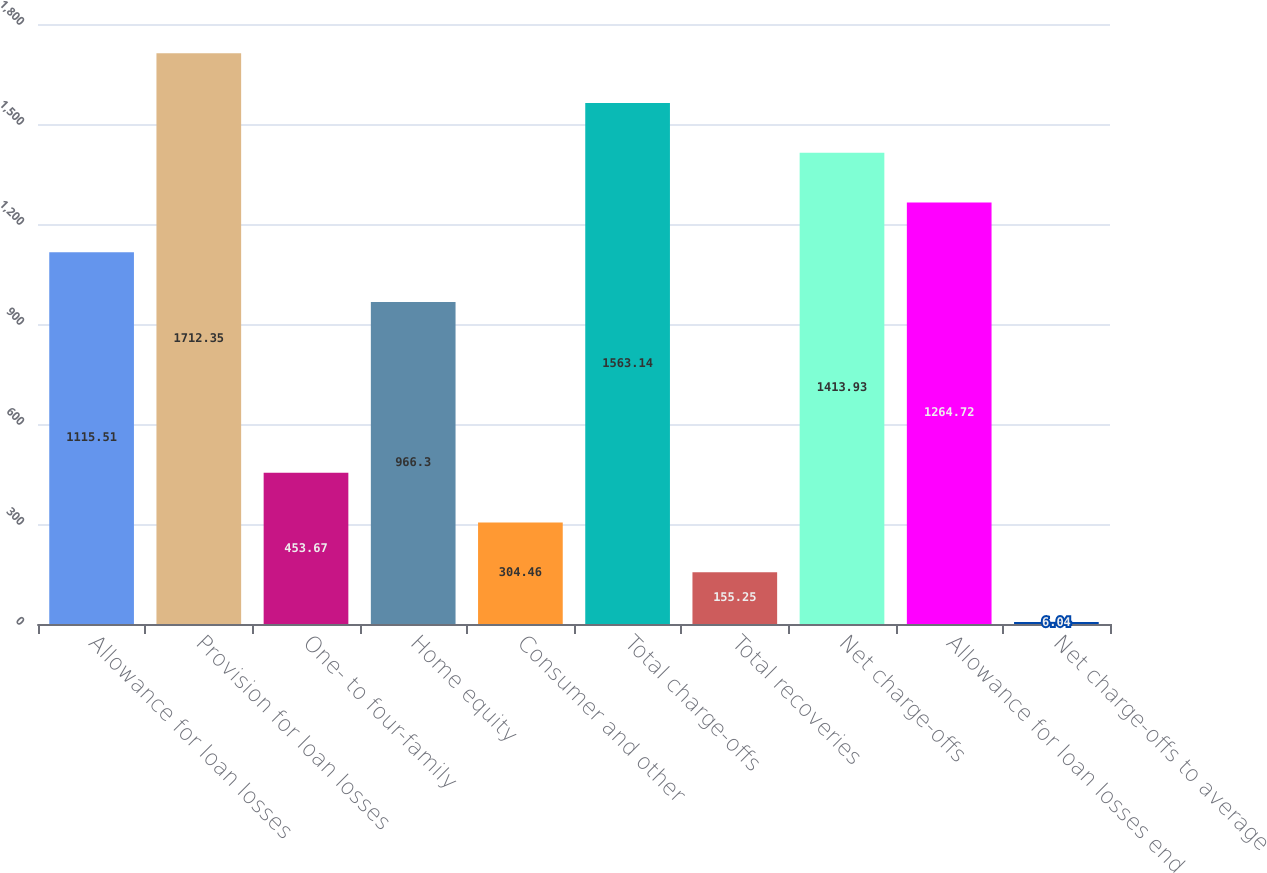<chart> <loc_0><loc_0><loc_500><loc_500><bar_chart><fcel>Allowance for loan losses<fcel>Provision for loan losses<fcel>One- to four-family<fcel>Home equity<fcel>Consumer and other<fcel>Total charge-offs<fcel>Total recoveries<fcel>Net charge-offs<fcel>Allowance for loan losses end<fcel>Net charge-offs to average<nl><fcel>1115.51<fcel>1712.35<fcel>453.67<fcel>966.3<fcel>304.46<fcel>1563.14<fcel>155.25<fcel>1413.93<fcel>1264.72<fcel>6.04<nl></chart> 